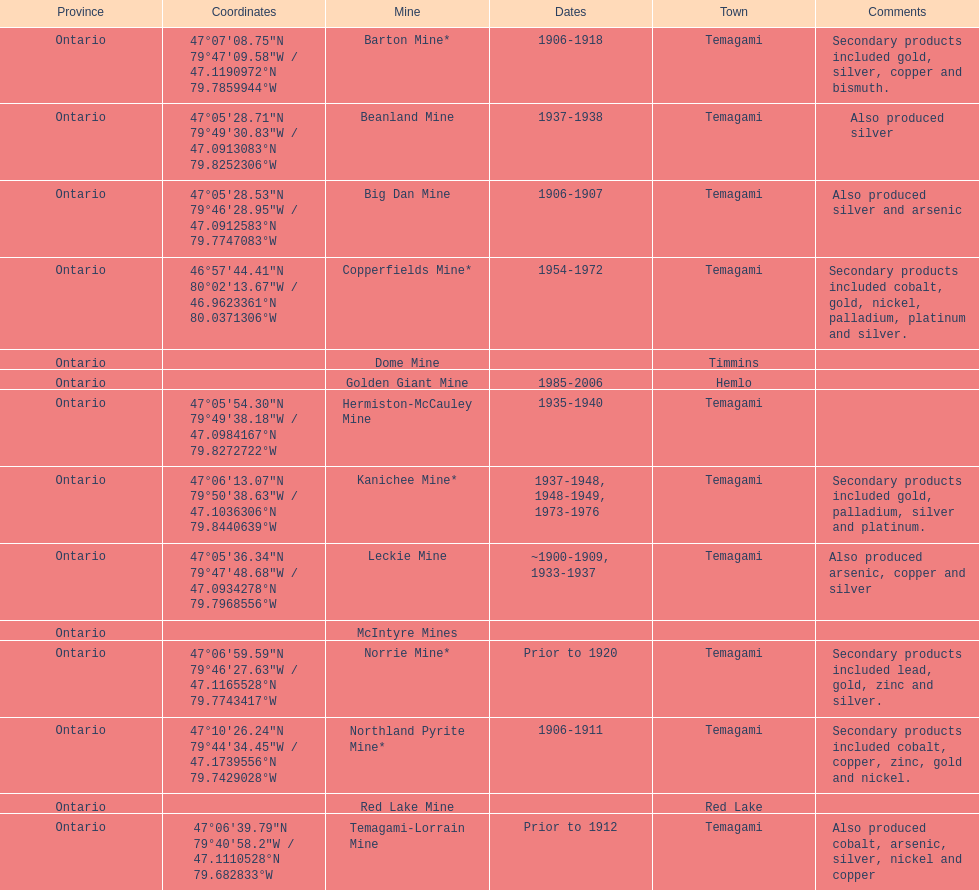What province is the town of temagami? Ontario. 